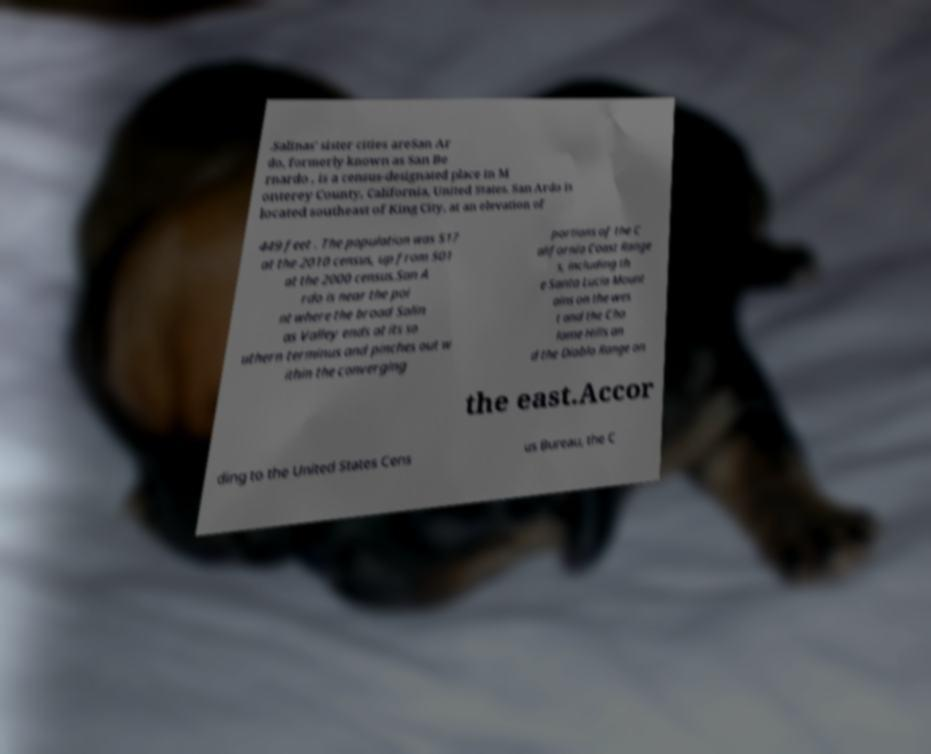There's text embedded in this image that I need extracted. Can you transcribe it verbatim? .Salinas' sister cities areSan Ar do, formerly known as San Be rnardo , is a census-designated place in M onterey County, California, United States. San Ardo is located southeast of King City, at an elevation of 449 feet . The population was 517 at the 2010 census, up from 501 at the 2000 census.San A rdo is near the poi nt where the broad Salin as Valley ends at its so uthern terminus and pinches out w ithin the converging portions of the C alifornia Coast Range s, including th e Santa Lucia Mount ains on the wes t and the Cho lame Hills an d the Diablo Range on the east.Accor ding to the United States Cens us Bureau, the C 